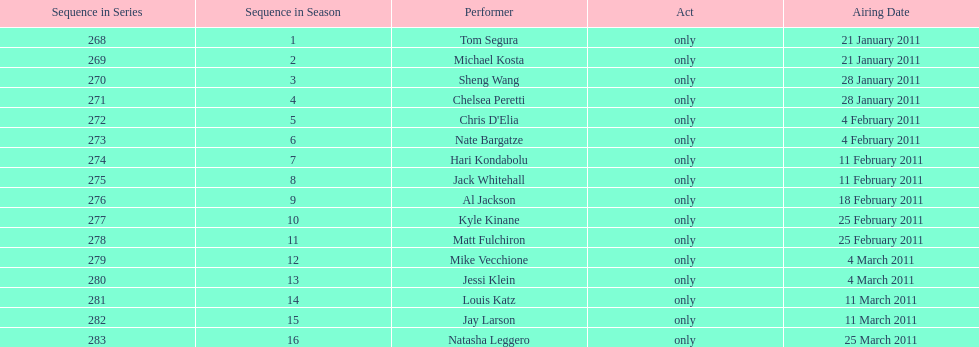How many episodes only had one performer? 16. 